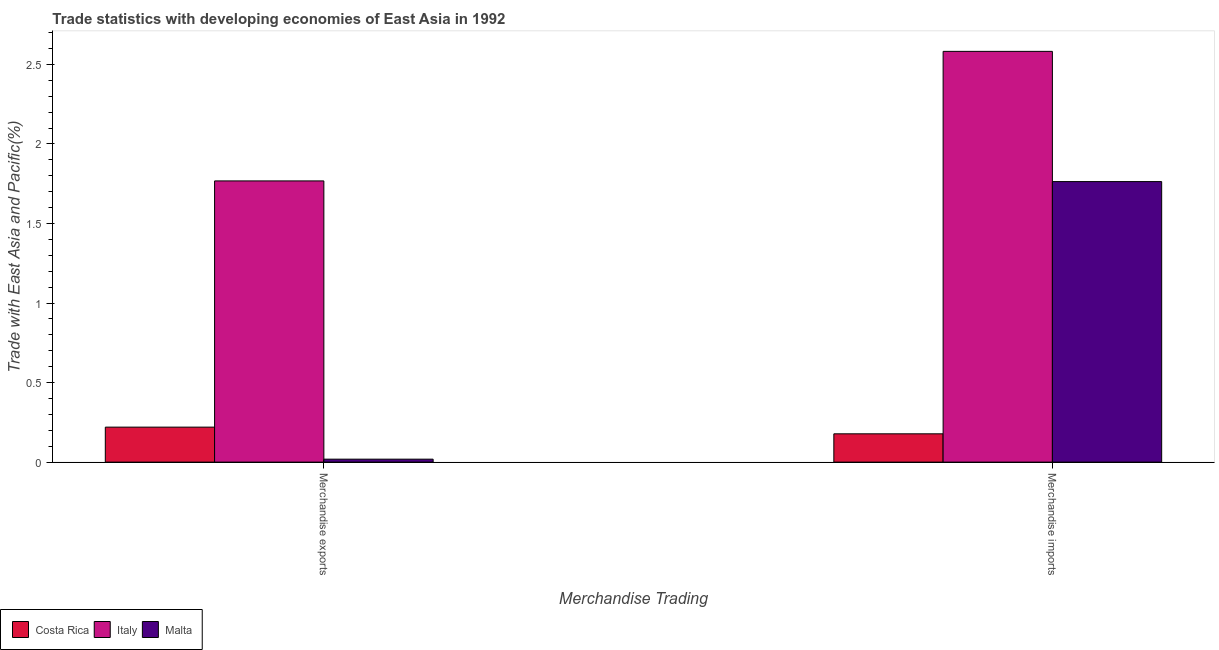Are the number of bars on each tick of the X-axis equal?
Ensure brevity in your answer.  Yes. How many bars are there on the 1st tick from the left?
Provide a succinct answer. 3. What is the merchandise exports in Malta?
Offer a very short reply. 0.02. Across all countries, what is the maximum merchandise imports?
Keep it short and to the point. 2.58. Across all countries, what is the minimum merchandise exports?
Your answer should be compact. 0.02. In which country was the merchandise exports minimum?
Offer a very short reply. Malta. What is the total merchandise exports in the graph?
Provide a succinct answer. 2.01. What is the difference between the merchandise imports in Italy and that in Malta?
Ensure brevity in your answer.  0.82. What is the difference between the merchandise imports in Malta and the merchandise exports in Italy?
Offer a very short reply. -0. What is the average merchandise imports per country?
Your answer should be compact. 1.51. What is the difference between the merchandise exports and merchandise imports in Costa Rica?
Provide a short and direct response. 0.04. What is the ratio of the merchandise exports in Costa Rica to that in Italy?
Keep it short and to the point. 0.12. Is the merchandise exports in Malta less than that in Italy?
Give a very brief answer. Yes. What does the 2nd bar from the right in Merchandise exports represents?
Provide a succinct answer. Italy. How many bars are there?
Offer a very short reply. 6. How many countries are there in the graph?
Offer a terse response. 3. Are the values on the major ticks of Y-axis written in scientific E-notation?
Give a very brief answer. No. How are the legend labels stacked?
Make the answer very short. Horizontal. What is the title of the graph?
Offer a very short reply. Trade statistics with developing economies of East Asia in 1992. Does "Middle East & North Africa (all income levels)" appear as one of the legend labels in the graph?
Provide a succinct answer. No. What is the label or title of the X-axis?
Your response must be concise. Merchandise Trading. What is the label or title of the Y-axis?
Make the answer very short. Trade with East Asia and Pacific(%). What is the Trade with East Asia and Pacific(%) in Costa Rica in Merchandise exports?
Offer a terse response. 0.22. What is the Trade with East Asia and Pacific(%) in Italy in Merchandise exports?
Offer a terse response. 1.77. What is the Trade with East Asia and Pacific(%) of Malta in Merchandise exports?
Ensure brevity in your answer.  0.02. What is the Trade with East Asia and Pacific(%) in Costa Rica in Merchandise imports?
Offer a very short reply. 0.18. What is the Trade with East Asia and Pacific(%) of Italy in Merchandise imports?
Your answer should be compact. 2.58. What is the Trade with East Asia and Pacific(%) in Malta in Merchandise imports?
Offer a terse response. 1.76. Across all Merchandise Trading, what is the maximum Trade with East Asia and Pacific(%) in Costa Rica?
Make the answer very short. 0.22. Across all Merchandise Trading, what is the maximum Trade with East Asia and Pacific(%) of Italy?
Offer a very short reply. 2.58. Across all Merchandise Trading, what is the maximum Trade with East Asia and Pacific(%) in Malta?
Keep it short and to the point. 1.76. Across all Merchandise Trading, what is the minimum Trade with East Asia and Pacific(%) in Costa Rica?
Offer a terse response. 0.18. Across all Merchandise Trading, what is the minimum Trade with East Asia and Pacific(%) in Italy?
Give a very brief answer. 1.77. Across all Merchandise Trading, what is the minimum Trade with East Asia and Pacific(%) in Malta?
Your answer should be very brief. 0.02. What is the total Trade with East Asia and Pacific(%) in Costa Rica in the graph?
Offer a very short reply. 0.4. What is the total Trade with East Asia and Pacific(%) of Italy in the graph?
Provide a short and direct response. 4.35. What is the total Trade with East Asia and Pacific(%) in Malta in the graph?
Your response must be concise. 1.78. What is the difference between the Trade with East Asia and Pacific(%) in Costa Rica in Merchandise exports and that in Merchandise imports?
Make the answer very short. 0.04. What is the difference between the Trade with East Asia and Pacific(%) of Italy in Merchandise exports and that in Merchandise imports?
Offer a very short reply. -0.81. What is the difference between the Trade with East Asia and Pacific(%) of Malta in Merchandise exports and that in Merchandise imports?
Your answer should be very brief. -1.74. What is the difference between the Trade with East Asia and Pacific(%) in Costa Rica in Merchandise exports and the Trade with East Asia and Pacific(%) in Italy in Merchandise imports?
Provide a short and direct response. -2.36. What is the difference between the Trade with East Asia and Pacific(%) in Costa Rica in Merchandise exports and the Trade with East Asia and Pacific(%) in Malta in Merchandise imports?
Give a very brief answer. -1.54. What is the difference between the Trade with East Asia and Pacific(%) in Italy in Merchandise exports and the Trade with East Asia and Pacific(%) in Malta in Merchandise imports?
Offer a very short reply. 0. What is the average Trade with East Asia and Pacific(%) in Costa Rica per Merchandise Trading?
Ensure brevity in your answer.  0.2. What is the average Trade with East Asia and Pacific(%) in Italy per Merchandise Trading?
Your answer should be very brief. 2.17. What is the average Trade with East Asia and Pacific(%) of Malta per Merchandise Trading?
Your response must be concise. 0.89. What is the difference between the Trade with East Asia and Pacific(%) in Costa Rica and Trade with East Asia and Pacific(%) in Italy in Merchandise exports?
Your answer should be very brief. -1.55. What is the difference between the Trade with East Asia and Pacific(%) of Costa Rica and Trade with East Asia and Pacific(%) of Malta in Merchandise exports?
Provide a succinct answer. 0.2. What is the difference between the Trade with East Asia and Pacific(%) of Italy and Trade with East Asia and Pacific(%) of Malta in Merchandise exports?
Provide a short and direct response. 1.75. What is the difference between the Trade with East Asia and Pacific(%) of Costa Rica and Trade with East Asia and Pacific(%) of Italy in Merchandise imports?
Offer a very short reply. -2.4. What is the difference between the Trade with East Asia and Pacific(%) of Costa Rica and Trade with East Asia and Pacific(%) of Malta in Merchandise imports?
Make the answer very short. -1.59. What is the difference between the Trade with East Asia and Pacific(%) of Italy and Trade with East Asia and Pacific(%) of Malta in Merchandise imports?
Your response must be concise. 0.82. What is the ratio of the Trade with East Asia and Pacific(%) in Costa Rica in Merchandise exports to that in Merchandise imports?
Offer a terse response. 1.24. What is the ratio of the Trade with East Asia and Pacific(%) in Italy in Merchandise exports to that in Merchandise imports?
Give a very brief answer. 0.68. What is the ratio of the Trade with East Asia and Pacific(%) of Malta in Merchandise exports to that in Merchandise imports?
Offer a very short reply. 0.01. What is the difference between the highest and the second highest Trade with East Asia and Pacific(%) of Costa Rica?
Keep it short and to the point. 0.04. What is the difference between the highest and the second highest Trade with East Asia and Pacific(%) of Italy?
Your answer should be compact. 0.81. What is the difference between the highest and the second highest Trade with East Asia and Pacific(%) in Malta?
Make the answer very short. 1.74. What is the difference between the highest and the lowest Trade with East Asia and Pacific(%) of Costa Rica?
Give a very brief answer. 0.04. What is the difference between the highest and the lowest Trade with East Asia and Pacific(%) of Italy?
Ensure brevity in your answer.  0.81. What is the difference between the highest and the lowest Trade with East Asia and Pacific(%) of Malta?
Your answer should be very brief. 1.74. 